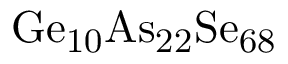<formula> <loc_0><loc_0><loc_500><loc_500>G e _ { 1 0 } A s _ { 2 2 } S e _ { 6 8 }</formula> 